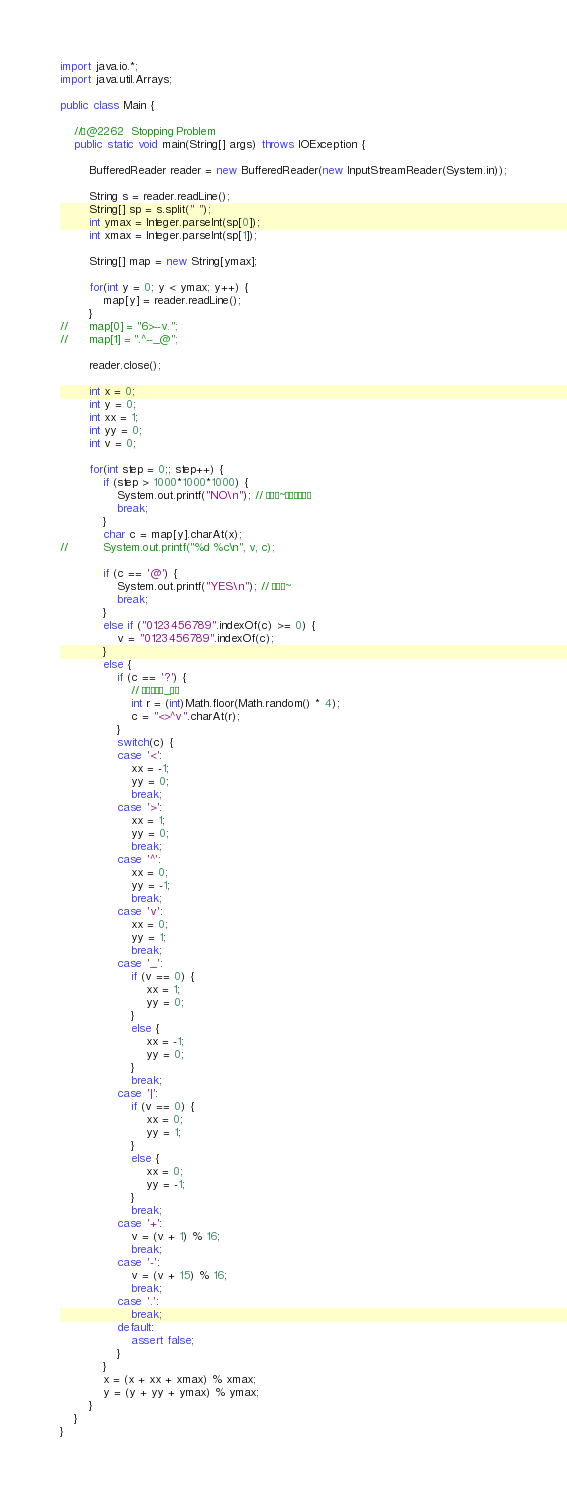<code> <loc_0><loc_0><loc_500><loc_500><_Java_>
import java.io.*;
import java.util.Arrays;

public class Main {

	//@2262  Stopping Problem
	public static void main(String[] args) throws IOException {
		
		BufferedReader reader = new BufferedReader(new InputStreamReader(System.in));

		String s = reader.readLine();
		String[] sp = s.split(" ");
		int ymax = Integer.parseInt(sp[0]);
		int xmax = Integer.parseInt(sp[1]);
		
		String[] map = new String[ymax];
		
		for(int y = 0; y < ymax; y++) {
			map[y] = reader.readLine();
		}
//		map[0] = "6>--v.";
//		map[1] = ".^--_@";
		
		reader.close();
		
		int x = 0;
		int y = 0;
		int xx = 1;
		int yy = 0;
		int v = 0;
		
		for(int step = 0;; step++) {
			if (step > 1000*1000*1000) {
				System.out.printf("NO\n"); // â~µÈ¢
				break;
			}
			char c = map[y].charAt(x);
//			System.out.printf("%d %c\n", v, c);
			
			if (c == '@') {
				System.out.printf("YES\n"); // â~
				break;
			}
			else if ("0123456789".indexOf(c) >= 0) {
				v = "0123456789".indexOf(c);
			}
			else {
				if (c == '?') {
					// _
					int r = (int)Math.floor(Math.random() * 4);
					c = "<>^v".charAt(r);
				}
				switch(c) {
				case '<':
					xx = -1;
					yy = 0;
					break;
				case '>':
					xx = 1;
					yy = 0;
					break;
				case '^':
					xx = 0;
					yy = -1;
					break;
				case 'v':
					xx = 0;
					yy = 1;
					break;
				case '_':
					if (v == 0) {
						xx = 1;
						yy = 0;
					}
					else {
						xx = -1;
						yy = 0;
					}
					break;
				case '|':
					if (v == 0) {
						xx = 0;
						yy = 1;
					}
					else {
						xx = 0;
						yy = -1;
					}
					break;
				case '+':
					v = (v + 1) % 16;
					break;
				case '-':
					v = (v + 15) % 16;
					break;
				case '.':
					break;
				default:
					assert false;
				}
			}
			x = (x + xx + xmax) % xmax;
			y = (y + yy + ymax) % ymax;
		}			
	}
}</code> 